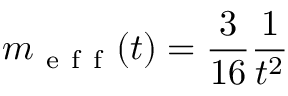Convert formula to latex. <formula><loc_0><loc_0><loc_500><loc_500>m _ { e f f } ( t ) = \frac { 3 } { 1 6 } \frac { 1 } { t ^ { 2 } }</formula> 